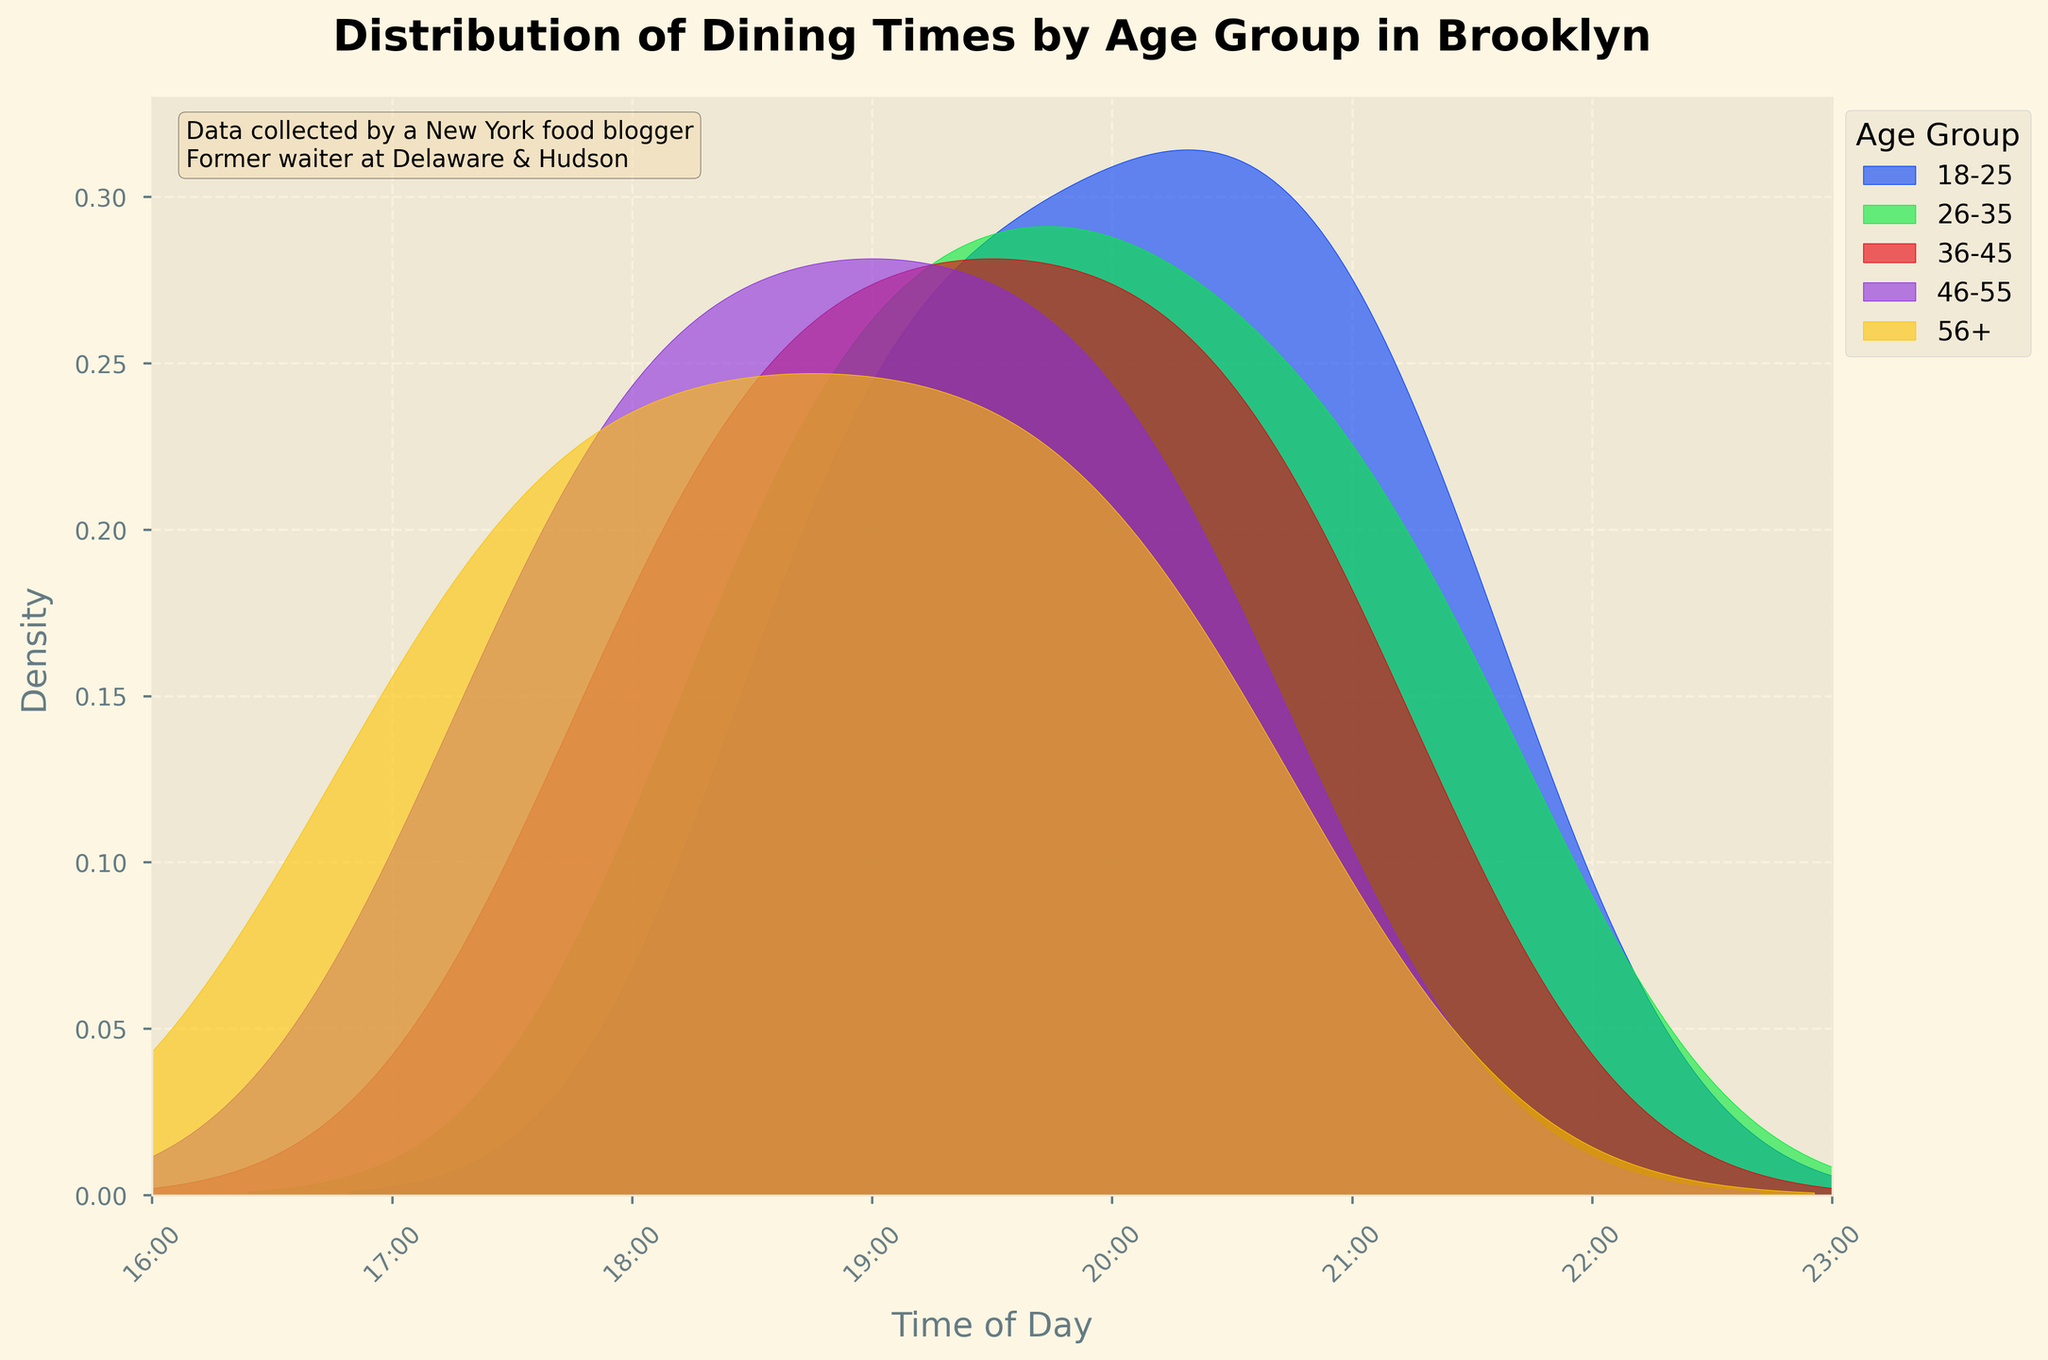What is the title of the plot? The title is usually at the top of the figure. For this plot, it is clearly displayed with larger, bolded text.
Answer: Distribution of Dining Times by Age Group in Brooklyn What is the time range represented on the x-axis? The x-axis typically shows the range of values being measured, and for this plot, the x-axis is labeled from 16 (4 PM) to 23 (11 PM).
Answer: 4 PM to 11 PM Which age group has the earliest dining peak time? To find the age group with the earliest peak, look for the density plot with the peak furthest to the left on the x-axis.
Answer: 56+ Which age group has a peak dining time closest to 7 PM? Identify the density curve that peaks around the 19:00 mark on the x-axis.
Answer: 36-45 What time frame shows the highest density of dining for the 18-25 age group? Look for the highest point on the 18-25 curve and note the corresponding time range on the x-axis.
Answer: Around 8:45 PM How do the dining times for the 46-55 age group compare to the 26-35 age group? Compare the peaks and density distribution of both age groups' curves. The 46-55 curve peaks earlier compared to the 26-35 curve.
Answer: Earlier Which age group has the most spread out dining times? Look at the width of each density curve. The broader the curve, the more spread out the dining times are.
Answer: 36-45 What is the trend of dining times as age increases? Examine the peaks of each age group's density curve and observe how they shift along the x-axis. Younger age groups dine later, and older age groups dine earlier.
Answer: Earlier dining times Are there any age groups that have overlapping peak dining times? Check if any density curves have peak points at or near the same x-axis value.
Answer: Yes, 26-35 and 36-45 around 8 PM What additional information is provided in the text box on the plot? Look at the text box located within the figure, usually providing context or additional details.
Answer: Data collected by a New York food blogger and former waiter at Delaware & Hudson 